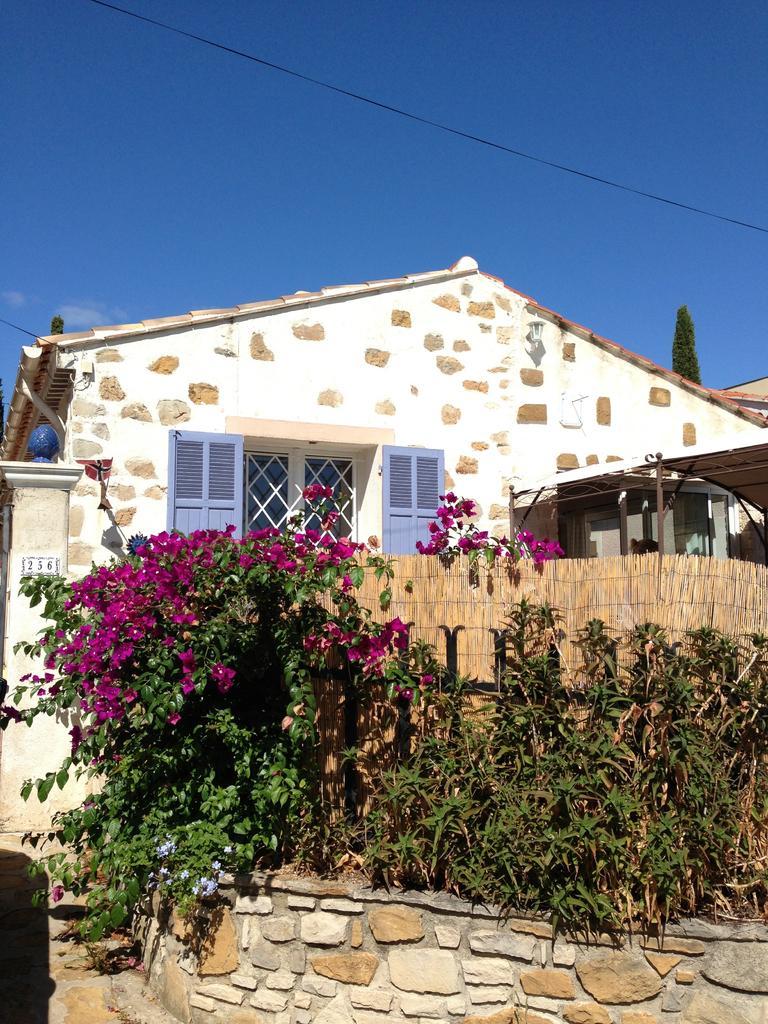Can you describe this image briefly? In this image there is a house, in front of the house there are a few plants and flowers, behind the house there is a tree. In the background there is the sky. 